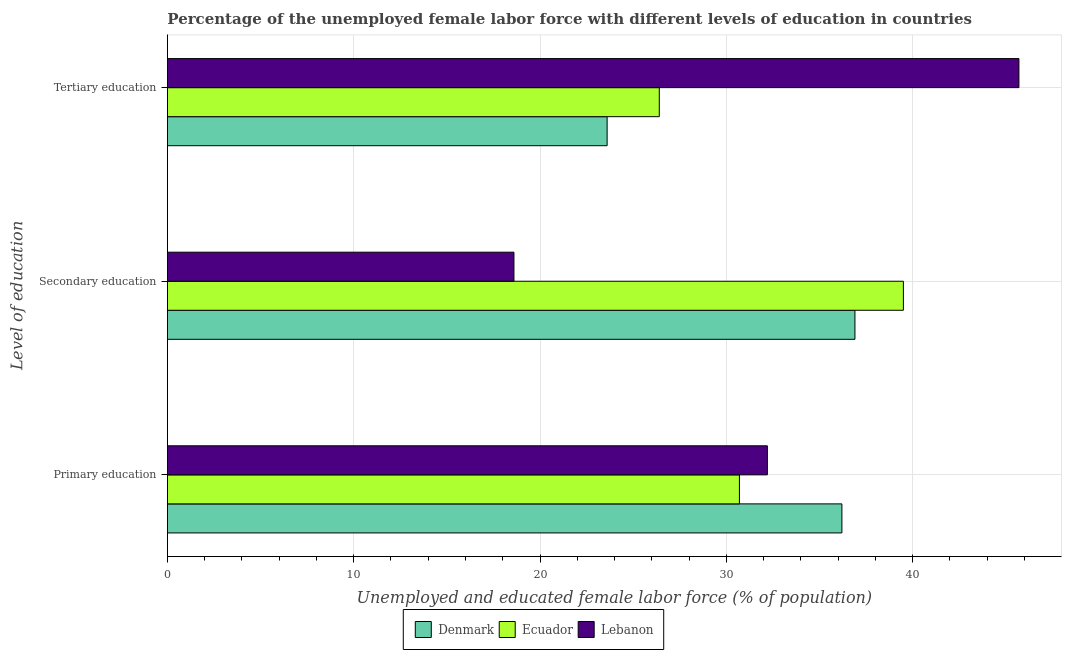How many different coloured bars are there?
Offer a very short reply. 3. Are the number of bars per tick equal to the number of legend labels?
Provide a succinct answer. Yes. Are the number of bars on each tick of the Y-axis equal?
Your answer should be compact. Yes. What is the label of the 2nd group of bars from the top?
Offer a terse response. Secondary education. What is the percentage of female labor force who received primary education in Lebanon?
Make the answer very short. 32.2. Across all countries, what is the maximum percentage of female labor force who received secondary education?
Give a very brief answer. 39.5. Across all countries, what is the minimum percentage of female labor force who received primary education?
Keep it short and to the point. 30.7. In which country was the percentage of female labor force who received tertiary education maximum?
Offer a terse response. Lebanon. In which country was the percentage of female labor force who received secondary education minimum?
Offer a very short reply. Lebanon. What is the total percentage of female labor force who received secondary education in the graph?
Keep it short and to the point. 95. What is the difference between the percentage of female labor force who received tertiary education in Denmark and that in Lebanon?
Make the answer very short. -22.1. What is the difference between the percentage of female labor force who received secondary education in Denmark and the percentage of female labor force who received primary education in Lebanon?
Your answer should be very brief. 4.7. What is the average percentage of female labor force who received tertiary education per country?
Keep it short and to the point. 31.9. What is the difference between the percentage of female labor force who received secondary education and percentage of female labor force who received primary education in Ecuador?
Make the answer very short. 8.8. In how many countries, is the percentage of female labor force who received primary education greater than 38 %?
Your answer should be compact. 0. What is the ratio of the percentage of female labor force who received tertiary education in Ecuador to that in Lebanon?
Your answer should be very brief. 0.58. Is the percentage of female labor force who received secondary education in Denmark less than that in Ecuador?
Your answer should be compact. Yes. What is the difference between the highest and the second highest percentage of female labor force who received tertiary education?
Offer a very short reply. 19.3. What is the difference between the highest and the lowest percentage of female labor force who received secondary education?
Ensure brevity in your answer.  20.9. In how many countries, is the percentage of female labor force who received secondary education greater than the average percentage of female labor force who received secondary education taken over all countries?
Keep it short and to the point. 2. Is the sum of the percentage of female labor force who received tertiary education in Lebanon and Ecuador greater than the maximum percentage of female labor force who received primary education across all countries?
Your response must be concise. Yes. What does the 2nd bar from the top in Tertiary education represents?
Provide a succinct answer. Ecuador. What does the 1st bar from the bottom in Primary education represents?
Offer a very short reply. Denmark. Is it the case that in every country, the sum of the percentage of female labor force who received primary education and percentage of female labor force who received secondary education is greater than the percentage of female labor force who received tertiary education?
Keep it short and to the point. Yes. Are all the bars in the graph horizontal?
Make the answer very short. Yes. Does the graph contain any zero values?
Offer a terse response. No. Does the graph contain grids?
Your answer should be very brief. Yes. How are the legend labels stacked?
Your answer should be very brief. Horizontal. What is the title of the graph?
Provide a succinct answer. Percentage of the unemployed female labor force with different levels of education in countries. Does "Honduras" appear as one of the legend labels in the graph?
Keep it short and to the point. No. What is the label or title of the X-axis?
Your response must be concise. Unemployed and educated female labor force (% of population). What is the label or title of the Y-axis?
Offer a very short reply. Level of education. What is the Unemployed and educated female labor force (% of population) in Denmark in Primary education?
Give a very brief answer. 36.2. What is the Unemployed and educated female labor force (% of population) in Ecuador in Primary education?
Your response must be concise. 30.7. What is the Unemployed and educated female labor force (% of population) of Lebanon in Primary education?
Your answer should be very brief. 32.2. What is the Unemployed and educated female labor force (% of population) of Denmark in Secondary education?
Your answer should be compact. 36.9. What is the Unemployed and educated female labor force (% of population) in Ecuador in Secondary education?
Provide a succinct answer. 39.5. What is the Unemployed and educated female labor force (% of population) of Lebanon in Secondary education?
Keep it short and to the point. 18.6. What is the Unemployed and educated female labor force (% of population) in Denmark in Tertiary education?
Provide a short and direct response. 23.6. What is the Unemployed and educated female labor force (% of population) of Ecuador in Tertiary education?
Offer a terse response. 26.4. What is the Unemployed and educated female labor force (% of population) in Lebanon in Tertiary education?
Offer a very short reply. 45.7. Across all Level of education, what is the maximum Unemployed and educated female labor force (% of population) in Denmark?
Your answer should be very brief. 36.9. Across all Level of education, what is the maximum Unemployed and educated female labor force (% of population) of Ecuador?
Ensure brevity in your answer.  39.5. Across all Level of education, what is the maximum Unemployed and educated female labor force (% of population) of Lebanon?
Ensure brevity in your answer.  45.7. Across all Level of education, what is the minimum Unemployed and educated female labor force (% of population) of Denmark?
Ensure brevity in your answer.  23.6. Across all Level of education, what is the minimum Unemployed and educated female labor force (% of population) in Ecuador?
Provide a short and direct response. 26.4. Across all Level of education, what is the minimum Unemployed and educated female labor force (% of population) in Lebanon?
Ensure brevity in your answer.  18.6. What is the total Unemployed and educated female labor force (% of population) of Denmark in the graph?
Keep it short and to the point. 96.7. What is the total Unemployed and educated female labor force (% of population) in Ecuador in the graph?
Offer a very short reply. 96.6. What is the total Unemployed and educated female labor force (% of population) in Lebanon in the graph?
Your answer should be very brief. 96.5. What is the difference between the Unemployed and educated female labor force (% of population) of Denmark in Primary education and that in Secondary education?
Offer a very short reply. -0.7. What is the difference between the Unemployed and educated female labor force (% of population) of Denmark in Primary education and that in Tertiary education?
Give a very brief answer. 12.6. What is the difference between the Unemployed and educated female labor force (% of population) of Lebanon in Primary education and that in Tertiary education?
Offer a terse response. -13.5. What is the difference between the Unemployed and educated female labor force (% of population) in Denmark in Secondary education and that in Tertiary education?
Keep it short and to the point. 13.3. What is the difference between the Unemployed and educated female labor force (% of population) of Ecuador in Secondary education and that in Tertiary education?
Make the answer very short. 13.1. What is the difference between the Unemployed and educated female labor force (% of population) of Lebanon in Secondary education and that in Tertiary education?
Give a very brief answer. -27.1. What is the difference between the Unemployed and educated female labor force (% of population) of Denmark in Primary education and the Unemployed and educated female labor force (% of population) of Lebanon in Secondary education?
Keep it short and to the point. 17.6. What is the difference between the Unemployed and educated female labor force (% of population) of Ecuador in Primary education and the Unemployed and educated female labor force (% of population) of Lebanon in Secondary education?
Give a very brief answer. 12.1. What is the difference between the Unemployed and educated female labor force (% of population) of Denmark in Primary education and the Unemployed and educated female labor force (% of population) of Ecuador in Tertiary education?
Give a very brief answer. 9.8. What is the difference between the Unemployed and educated female labor force (% of population) of Denmark in Secondary education and the Unemployed and educated female labor force (% of population) of Ecuador in Tertiary education?
Your answer should be compact. 10.5. What is the difference between the Unemployed and educated female labor force (% of population) in Denmark in Secondary education and the Unemployed and educated female labor force (% of population) in Lebanon in Tertiary education?
Make the answer very short. -8.8. What is the average Unemployed and educated female labor force (% of population) in Denmark per Level of education?
Your answer should be very brief. 32.23. What is the average Unemployed and educated female labor force (% of population) in Ecuador per Level of education?
Give a very brief answer. 32.2. What is the average Unemployed and educated female labor force (% of population) in Lebanon per Level of education?
Your answer should be very brief. 32.17. What is the difference between the Unemployed and educated female labor force (% of population) in Denmark and Unemployed and educated female labor force (% of population) in Ecuador in Primary education?
Keep it short and to the point. 5.5. What is the difference between the Unemployed and educated female labor force (% of population) in Denmark and Unemployed and educated female labor force (% of population) in Ecuador in Secondary education?
Your answer should be compact. -2.6. What is the difference between the Unemployed and educated female labor force (% of population) of Ecuador and Unemployed and educated female labor force (% of population) of Lebanon in Secondary education?
Provide a short and direct response. 20.9. What is the difference between the Unemployed and educated female labor force (% of population) in Denmark and Unemployed and educated female labor force (% of population) in Lebanon in Tertiary education?
Give a very brief answer. -22.1. What is the difference between the Unemployed and educated female labor force (% of population) of Ecuador and Unemployed and educated female labor force (% of population) of Lebanon in Tertiary education?
Keep it short and to the point. -19.3. What is the ratio of the Unemployed and educated female labor force (% of population) of Ecuador in Primary education to that in Secondary education?
Give a very brief answer. 0.78. What is the ratio of the Unemployed and educated female labor force (% of population) in Lebanon in Primary education to that in Secondary education?
Your answer should be very brief. 1.73. What is the ratio of the Unemployed and educated female labor force (% of population) of Denmark in Primary education to that in Tertiary education?
Your response must be concise. 1.53. What is the ratio of the Unemployed and educated female labor force (% of population) of Ecuador in Primary education to that in Tertiary education?
Keep it short and to the point. 1.16. What is the ratio of the Unemployed and educated female labor force (% of population) in Lebanon in Primary education to that in Tertiary education?
Offer a very short reply. 0.7. What is the ratio of the Unemployed and educated female labor force (% of population) of Denmark in Secondary education to that in Tertiary education?
Provide a succinct answer. 1.56. What is the ratio of the Unemployed and educated female labor force (% of population) in Ecuador in Secondary education to that in Tertiary education?
Your answer should be very brief. 1.5. What is the ratio of the Unemployed and educated female labor force (% of population) in Lebanon in Secondary education to that in Tertiary education?
Make the answer very short. 0.41. What is the difference between the highest and the second highest Unemployed and educated female labor force (% of population) of Ecuador?
Keep it short and to the point. 8.8. What is the difference between the highest and the second highest Unemployed and educated female labor force (% of population) of Lebanon?
Your answer should be very brief. 13.5. What is the difference between the highest and the lowest Unemployed and educated female labor force (% of population) of Ecuador?
Provide a succinct answer. 13.1. What is the difference between the highest and the lowest Unemployed and educated female labor force (% of population) of Lebanon?
Keep it short and to the point. 27.1. 